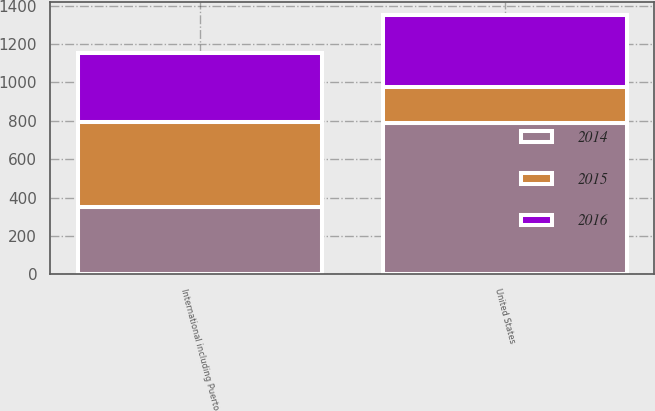Convert chart. <chart><loc_0><loc_0><loc_500><loc_500><stacked_bar_chart><ecel><fcel>United States<fcel>International including Puerto<nl><fcel>2016<fcel>378.2<fcel>359.7<nl><fcel>2015<fcel>182.8<fcel>439.6<nl><fcel>2014<fcel>791.1<fcel>352.9<nl></chart> 